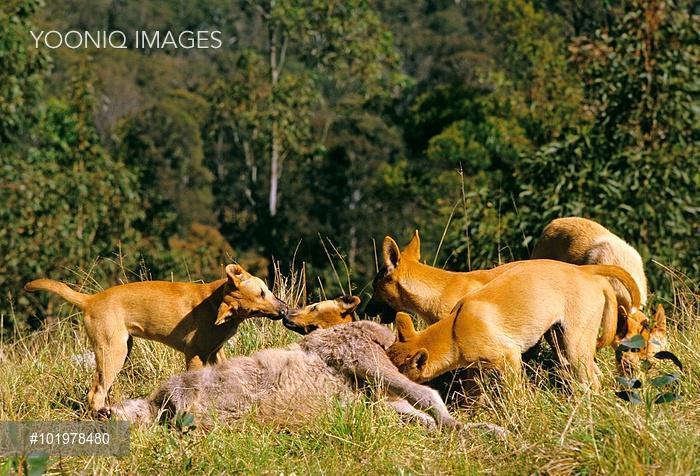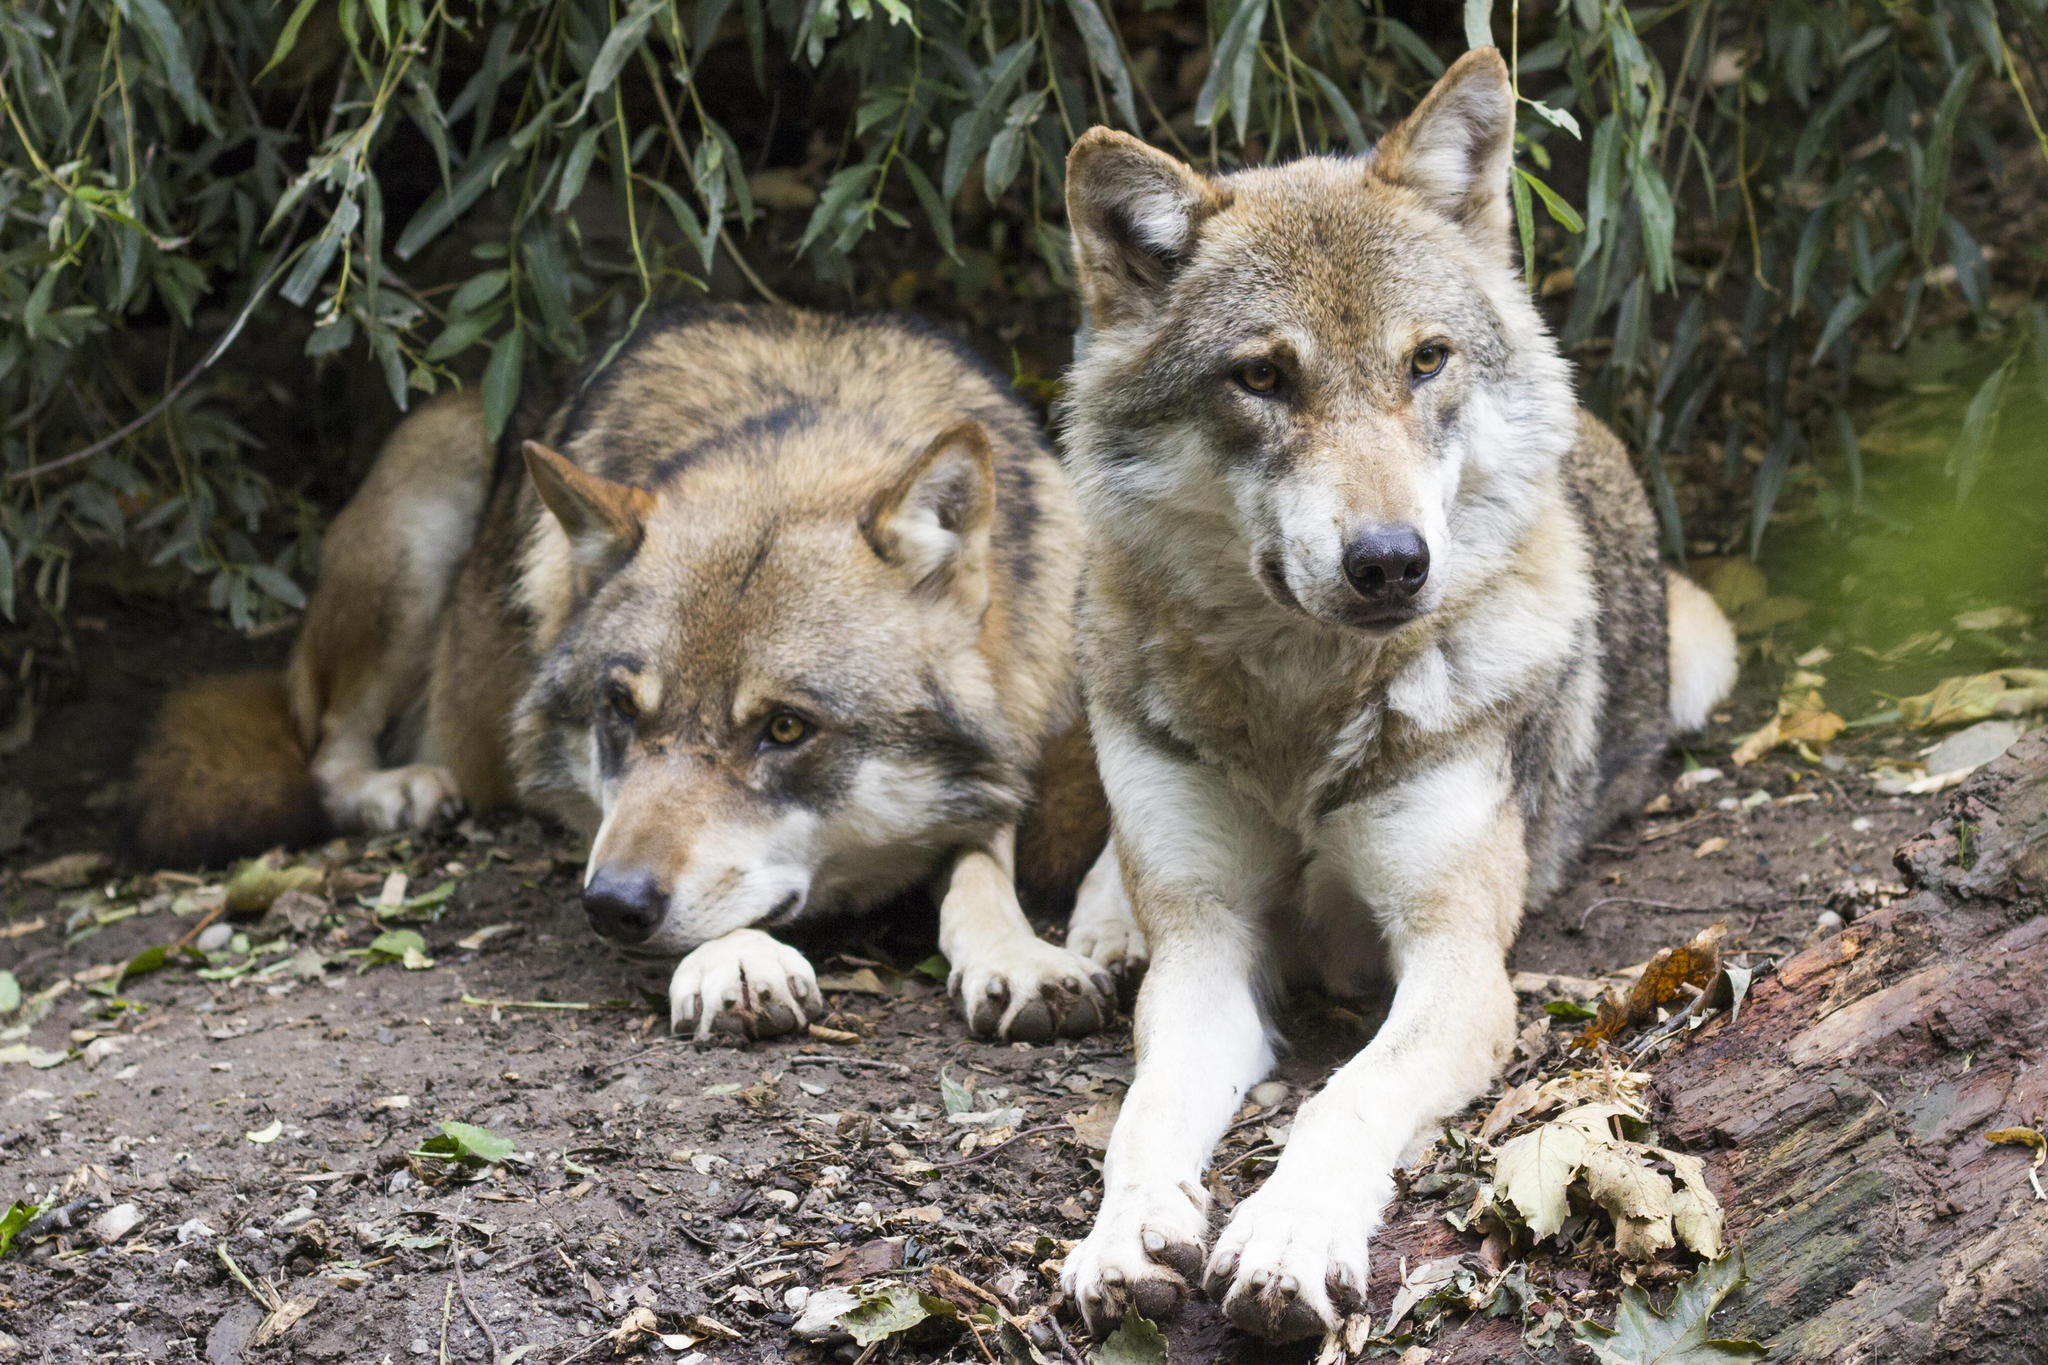The first image is the image on the left, the second image is the image on the right. Assess this claim about the two images: "there are 2 wolves, one is in the back laying down under a shrub with willowy leaves, there is dirt under them with dead leaves on the ground". Correct or not? Answer yes or no. Yes. The first image is the image on the left, the second image is the image on the right. Analyze the images presented: Is the assertion "There are two wolves  outside with at least one laying down in the dirt." valid? Answer yes or no. Yes. 